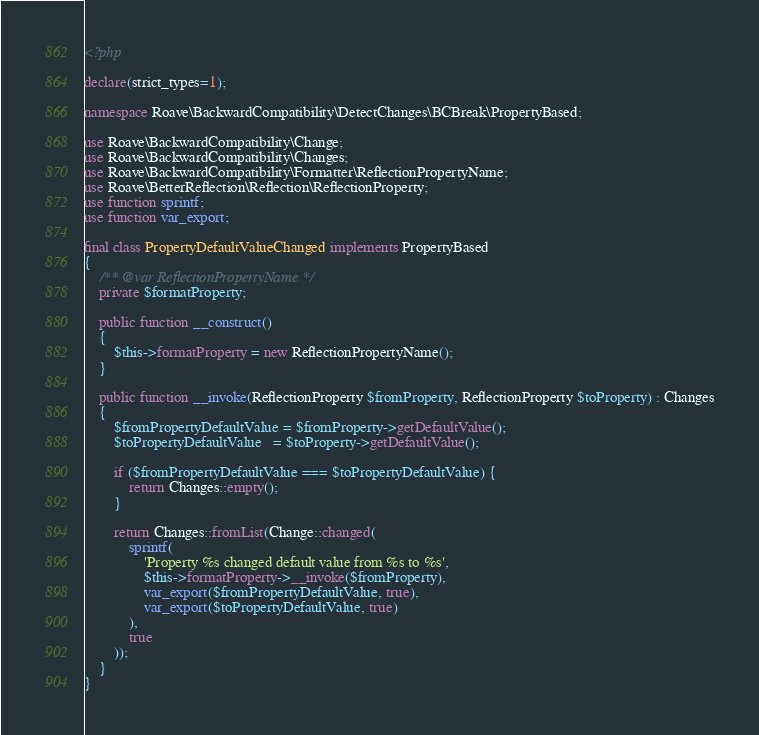Convert code to text. <code><loc_0><loc_0><loc_500><loc_500><_PHP_><?php

declare(strict_types=1);

namespace Roave\BackwardCompatibility\DetectChanges\BCBreak\PropertyBased;

use Roave\BackwardCompatibility\Change;
use Roave\BackwardCompatibility\Changes;
use Roave\BackwardCompatibility\Formatter\ReflectionPropertyName;
use Roave\BetterReflection\Reflection\ReflectionProperty;
use function sprintf;
use function var_export;

final class PropertyDefaultValueChanged implements PropertyBased
{
    /** @var ReflectionPropertyName */
    private $formatProperty;

    public function __construct()
    {
        $this->formatProperty = new ReflectionPropertyName();
    }

    public function __invoke(ReflectionProperty $fromProperty, ReflectionProperty $toProperty) : Changes
    {
        $fromPropertyDefaultValue = $fromProperty->getDefaultValue();
        $toPropertyDefaultValue   = $toProperty->getDefaultValue();

        if ($fromPropertyDefaultValue === $toPropertyDefaultValue) {
            return Changes::empty();
        }

        return Changes::fromList(Change::changed(
            sprintf(
                'Property %s changed default value from %s to %s',
                $this->formatProperty->__invoke($fromProperty),
                var_export($fromPropertyDefaultValue, true),
                var_export($toPropertyDefaultValue, true)
            ),
            true
        ));
    }
}
</code> 